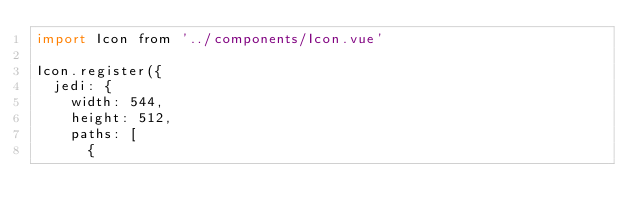<code> <loc_0><loc_0><loc_500><loc_500><_JavaScript_>import Icon from '../components/Icon.vue'

Icon.register({
  jedi: {
    width: 544,
    height: 512,
    paths: [
      {</code> 